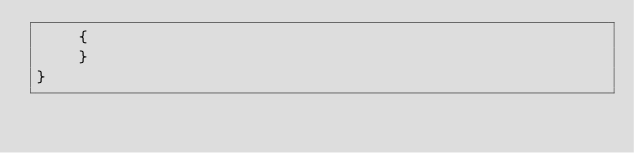<code> <loc_0><loc_0><loc_500><loc_500><_C#_>    {
    }
}</code> 